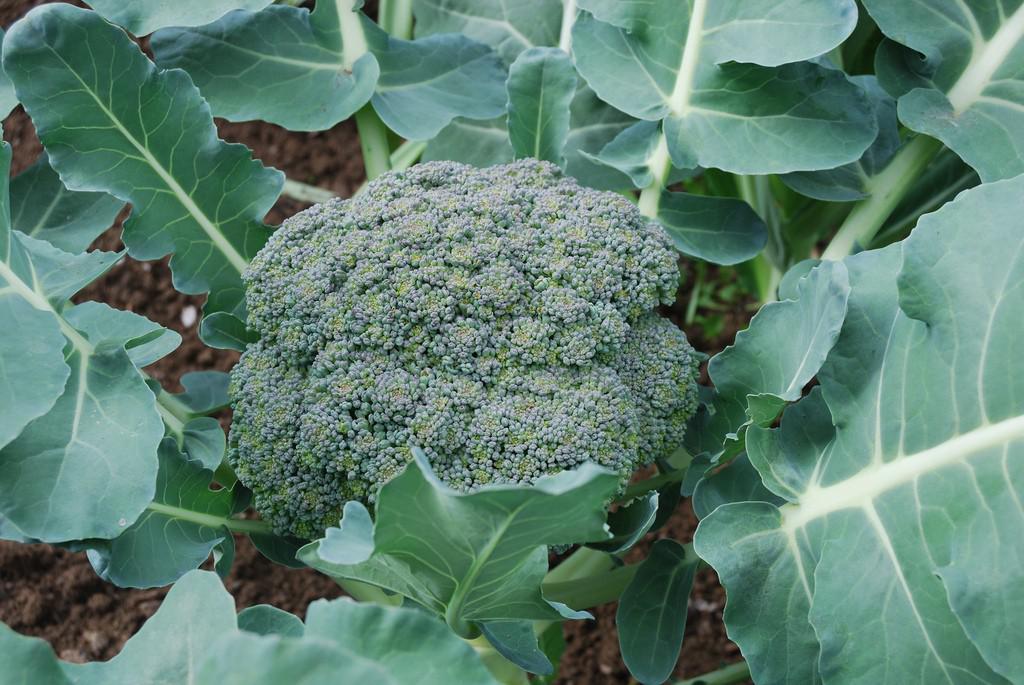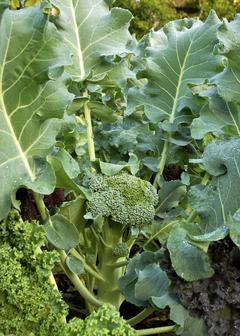The first image is the image on the left, the second image is the image on the right. Analyze the images presented: Is the assertion "The plants are entirely green." valid? Answer yes or no. Yes. The first image is the image on the left, the second image is the image on the right. Analyze the images presented: Is the assertion "The left and right image contains the same number of growing broccoli with at least one flowering." valid? Answer yes or no. No. 